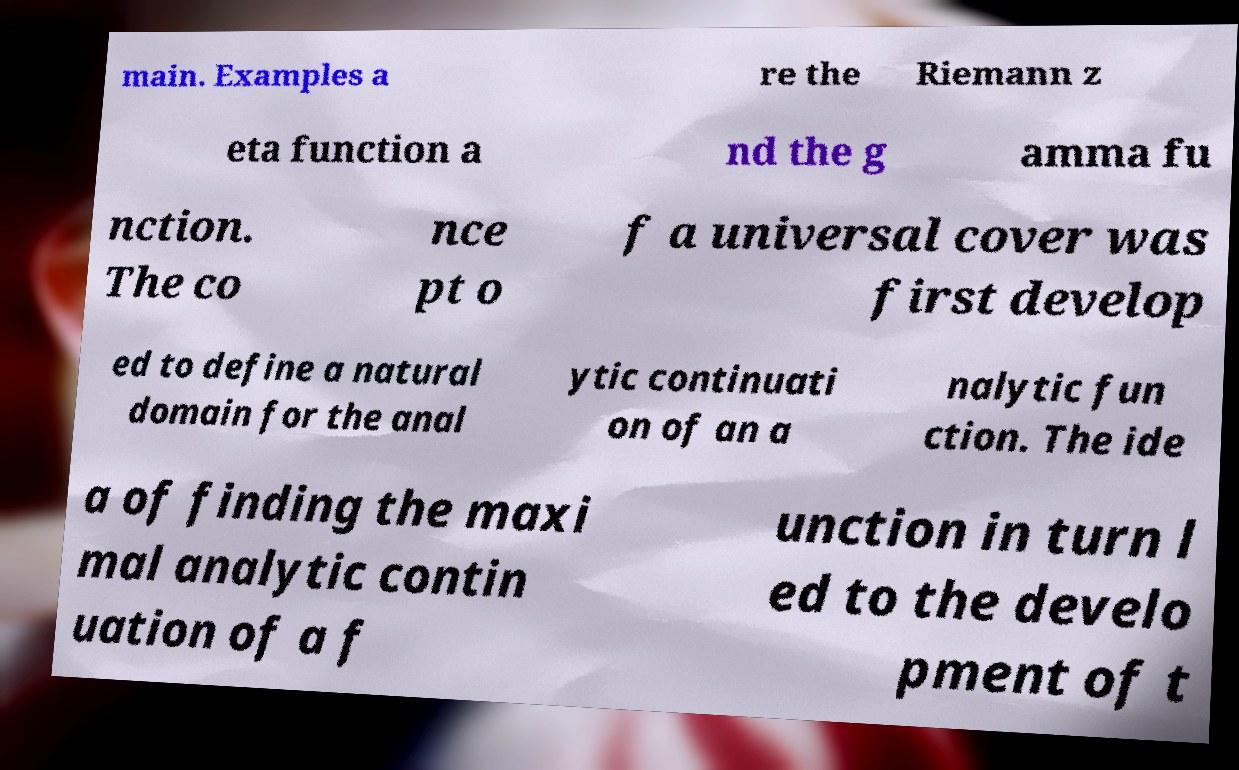Please read and relay the text visible in this image. What does it say? main. Examples a re the Riemann z eta function a nd the g amma fu nction. The co nce pt o f a universal cover was first develop ed to define a natural domain for the anal ytic continuati on of an a nalytic fun ction. The ide a of finding the maxi mal analytic contin uation of a f unction in turn l ed to the develo pment of t 